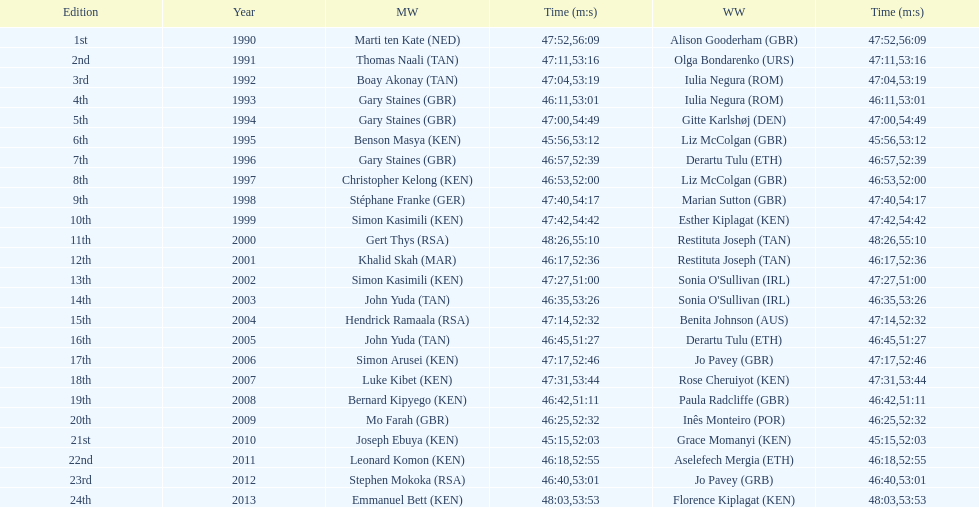How many men winners had times at least 46 minutes or under? 2. 